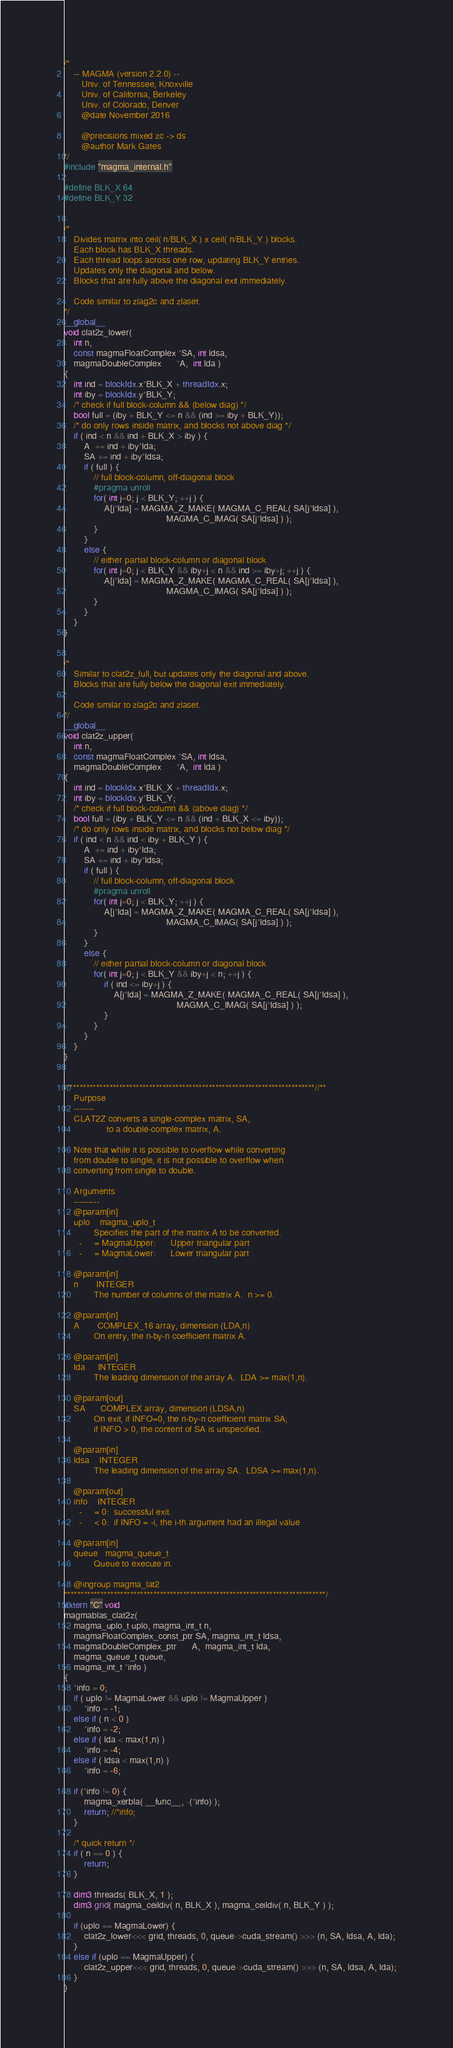<code> <loc_0><loc_0><loc_500><loc_500><_Cuda_>/*
    -- MAGMA (version 2.2.0) --
       Univ. of Tennessee, Knoxville
       Univ. of California, Berkeley
       Univ. of Colorado, Denver
       @date November 2016

       @precisions mixed zc -> ds
       @author Mark Gates
*/
#include "magma_internal.h"

#define BLK_X 64
#define BLK_Y 32


/*
    Divides matrix into ceil( n/BLK_X ) x ceil( n/BLK_Y ) blocks.
    Each block has BLK_X threads.
    Each thread loops across one row, updating BLK_Y entries.
    Updates only the diagonal and below.
    Blocks that are fully above the diagonal exit immediately.
    
    Code similar to zlag2c and zlaset.
*/
__global__
void clat2z_lower(
    int n,
    const magmaFloatComplex *SA, int ldsa,
    magmaDoubleComplex      *A,  int lda )
{
    int ind = blockIdx.x*BLK_X + threadIdx.x;
    int iby = blockIdx.y*BLK_Y;
    /* check if full block-column && (below diag) */
    bool full = (iby + BLK_Y <= n && (ind >= iby + BLK_Y));
    /* do only rows inside matrix, and blocks not above diag */
    if ( ind < n && ind + BLK_X > iby ) {
        A  += ind + iby*lda;
        SA += ind + iby*ldsa;
        if ( full ) {
            // full block-column, off-diagonal block
            #pragma unroll
            for( int j=0; j < BLK_Y; ++j ) {
                A[j*lda] = MAGMA_Z_MAKE( MAGMA_C_REAL( SA[j*ldsa] ),
                                         MAGMA_C_IMAG( SA[j*ldsa] ) );
            }
        }
        else {
            // either partial block-column or diagonal block
            for( int j=0; j < BLK_Y && iby+j < n && ind >= iby+j; ++j ) {
                A[j*lda] = MAGMA_Z_MAKE( MAGMA_C_REAL( SA[j*ldsa] ),
                                         MAGMA_C_IMAG( SA[j*ldsa] ) );
            }
        }
    }
}


/*
    Similar to clat2z_full, but updates only the diagonal and above.
    Blocks that are fully below the diagonal exit immediately.
    
    Code similar to zlag2c and zlaset.
*/
__global__
void clat2z_upper(
    int n,
    const magmaFloatComplex *SA, int ldsa,
    magmaDoubleComplex      *A,  int lda )
{
    int ind = blockIdx.x*BLK_X + threadIdx.x;
    int iby = blockIdx.y*BLK_Y;
    /* check if full block-column && (above diag) */
    bool full = (iby + BLK_Y <= n && (ind + BLK_X <= iby));
    /* do only rows inside matrix, and blocks not below diag */
    if ( ind < n && ind < iby + BLK_Y ) {
        A  += ind + iby*lda;
        SA += ind + iby*ldsa;
        if ( full ) {
            // full block-column, off-diagonal block
            #pragma unroll
            for( int j=0; j < BLK_Y; ++j ) {
                A[j*lda] = MAGMA_Z_MAKE( MAGMA_C_REAL( SA[j*ldsa] ),
                                         MAGMA_C_IMAG( SA[j*ldsa] ) );
            }
        }
        else {
            // either partial block-column or diagonal block
            for( int j=0; j < BLK_Y && iby+j < n; ++j ) {
                if ( ind <= iby+j ) {
                    A[j*lda] = MAGMA_Z_MAKE( MAGMA_C_REAL( SA[j*ldsa] ),
                                             MAGMA_C_IMAG( SA[j*ldsa] ) );
                }
            }
        }
    }
}


/***************************************************************************//**
    Purpose
    -------
    CLAT2Z converts a single-complex matrix, SA,
                 to a double-complex matrix, A.

    Note that while it is possible to overflow while converting
    from double to single, it is not possible to overflow when
    converting from single to double.

    Arguments
    ---------
    @param[in]
    uplo    magma_uplo_t
            Specifies the part of the matrix A to be converted.
      -     = MagmaUpper:      Upper triangular part
      -     = MagmaLower:      Lower triangular part
    
    @param[in]
    n       INTEGER
            The number of columns of the matrix A.  n >= 0.
    
    @param[in]
    A       COMPLEX_16 array, dimension (LDA,n)
            On entry, the n-by-n coefficient matrix A.
    
    @param[in]
    lda     INTEGER
            The leading dimension of the array A.  LDA >= max(1,n).
    
    @param[out]
    SA      COMPLEX array, dimension (LDSA,n)
            On exit, if INFO=0, the n-by-n coefficient matrix SA;
            if INFO > 0, the content of SA is unspecified.
    
    @param[in]
    ldsa    INTEGER
            The leading dimension of the array SA.  LDSA >= max(1,n).
    
    @param[out]
    info    INTEGER
      -     = 0:  successful exit.
      -     < 0:  if INFO = -i, the i-th argument had an illegal value
    
    @param[in]
    queue   magma_queue_t
            Queue to execute in.
    
    @ingroup magma_lat2
*******************************************************************************/
extern "C" void
magmablas_clat2z(
    magma_uplo_t uplo, magma_int_t n,
    magmaFloatComplex_const_ptr SA, magma_int_t ldsa,
    magmaDoubleComplex_ptr      A,  magma_int_t lda,
    magma_queue_t queue,
    magma_int_t *info )
{
    *info = 0;
    if ( uplo != MagmaLower && uplo != MagmaUpper )
        *info = -1;
    else if ( n < 0 )
        *info = -2;
    else if ( lda < max(1,n) )
        *info = -4;
    else if ( ldsa < max(1,n) )
        *info = -6;
    
    if (*info != 0) {
        magma_xerbla( __func__, -(*info) );
        return; //*info;
    }

    /* quick return */
    if ( n == 0 ) {
        return;
    }
    
    dim3 threads( BLK_X, 1 );
    dim3 grid( magma_ceildiv( n, BLK_X ), magma_ceildiv( n, BLK_Y ) );
    
    if (uplo == MagmaLower) {
        clat2z_lower<<< grid, threads, 0, queue->cuda_stream() >>> (n, SA, ldsa, A, lda);
    }
    else if (uplo == MagmaUpper) {
        clat2z_upper<<< grid, threads, 0, queue->cuda_stream() >>> (n, SA, ldsa, A, lda);
    }
}
</code> 